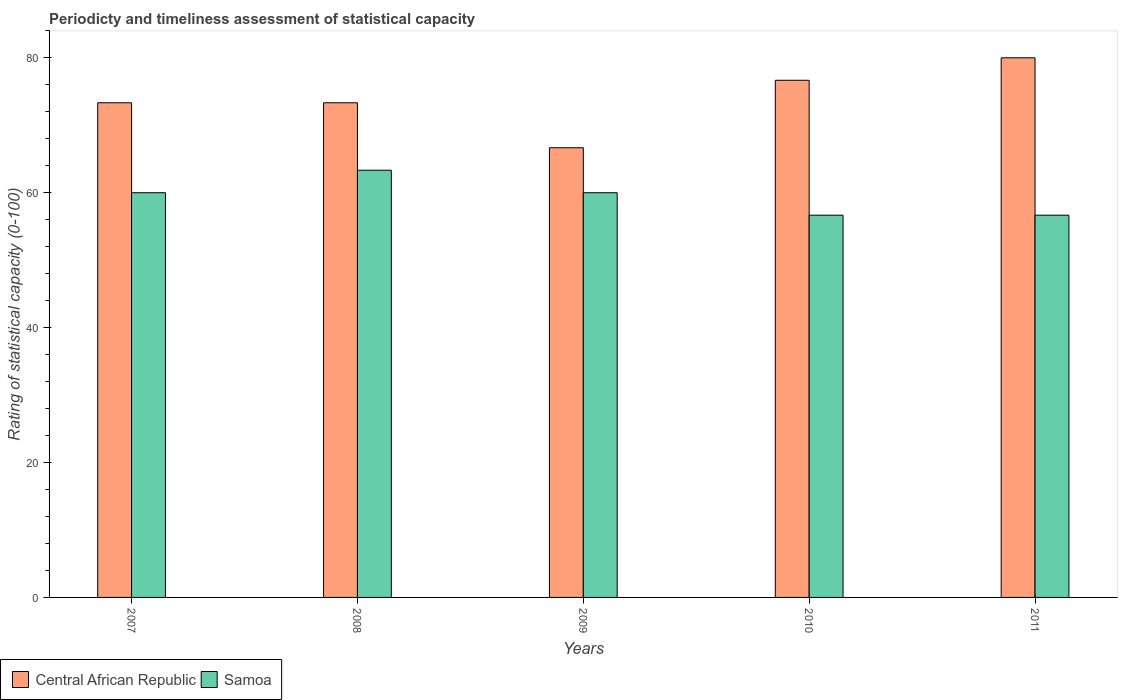How many bars are there on the 5th tick from the right?
Provide a succinct answer. 2. What is the rating of statistical capacity in Central African Republic in 2008?
Give a very brief answer. 73.33. Across all years, what is the maximum rating of statistical capacity in Samoa?
Keep it short and to the point. 63.33. Across all years, what is the minimum rating of statistical capacity in Samoa?
Ensure brevity in your answer.  56.67. What is the total rating of statistical capacity in Central African Republic in the graph?
Provide a short and direct response. 370. What is the difference between the rating of statistical capacity in Central African Republic in 2007 and that in 2010?
Your response must be concise. -3.33. What is the difference between the rating of statistical capacity in Samoa in 2010 and the rating of statistical capacity in Central African Republic in 2009?
Your answer should be very brief. -10. What is the average rating of statistical capacity in Samoa per year?
Your answer should be compact. 59.33. In the year 2009, what is the difference between the rating of statistical capacity in Central African Republic and rating of statistical capacity in Samoa?
Offer a very short reply. 6.67. In how many years, is the rating of statistical capacity in Central African Republic greater than 52?
Offer a very short reply. 5. What is the ratio of the rating of statistical capacity in Samoa in 2007 to that in 2011?
Offer a very short reply. 1.06. Is the rating of statistical capacity in Samoa in 2008 less than that in 2010?
Your response must be concise. No. Is the difference between the rating of statistical capacity in Central African Republic in 2009 and 2010 greater than the difference between the rating of statistical capacity in Samoa in 2009 and 2010?
Provide a succinct answer. No. What is the difference between the highest and the second highest rating of statistical capacity in Samoa?
Provide a succinct answer. 3.33. What is the difference between the highest and the lowest rating of statistical capacity in Samoa?
Give a very brief answer. 6.67. In how many years, is the rating of statistical capacity in Samoa greater than the average rating of statistical capacity in Samoa taken over all years?
Keep it short and to the point. 3. What does the 2nd bar from the left in 2010 represents?
Your answer should be very brief. Samoa. What does the 1st bar from the right in 2008 represents?
Make the answer very short. Samoa. Does the graph contain any zero values?
Offer a very short reply. No. Does the graph contain grids?
Offer a very short reply. No. Where does the legend appear in the graph?
Provide a short and direct response. Bottom left. How are the legend labels stacked?
Keep it short and to the point. Horizontal. What is the title of the graph?
Your answer should be very brief. Periodicty and timeliness assessment of statistical capacity. Does "Andorra" appear as one of the legend labels in the graph?
Your response must be concise. No. What is the label or title of the X-axis?
Keep it short and to the point. Years. What is the label or title of the Y-axis?
Offer a terse response. Rating of statistical capacity (0-100). What is the Rating of statistical capacity (0-100) in Central African Republic in 2007?
Ensure brevity in your answer.  73.33. What is the Rating of statistical capacity (0-100) of Central African Republic in 2008?
Keep it short and to the point. 73.33. What is the Rating of statistical capacity (0-100) of Samoa in 2008?
Your answer should be very brief. 63.33. What is the Rating of statistical capacity (0-100) in Central African Republic in 2009?
Your answer should be very brief. 66.67. What is the Rating of statistical capacity (0-100) in Central African Republic in 2010?
Keep it short and to the point. 76.67. What is the Rating of statistical capacity (0-100) of Samoa in 2010?
Offer a very short reply. 56.67. What is the Rating of statistical capacity (0-100) in Samoa in 2011?
Ensure brevity in your answer.  56.67. Across all years, what is the maximum Rating of statistical capacity (0-100) in Samoa?
Offer a very short reply. 63.33. Across all years, what is the minimum Rating of statistical capacity (0-100) in Central African Republic?
Offer a terse response. 66.67. Across all years, what is the minimum Rating of statistical capacity (0-100) in Samoa?
Ensure brevity in your answer.  56.67. What is the total Rating of statistical capacity (0-100) in Central African Republic in the graph?
Provide a succinct answer. 370. What is the total Rating of statistical capacity (0-100) in Samoa in the graph?
Provide a succinct answer. 296.67. What is the difference between the Rating of statistical capacity (0-100) of Central African Republic in 2007 and that in 2008?
Ensure brevity in your answer.  0. What is the difference between the Rating of statistical capacity (0-100) of Central African Republic in 2007 and that in 2009?
Offer a terse response. 6.67. What is the difference between the Rating of statistical capacity (0-100) of Samoa in 2007 and that in 2009?
Make the answer very short. 0. What is the difference between the Rating of statistical capacity (0-100) in Central African Republic in 2007 and that in 2011?
Ensure brevity in your answer.  -6.67. What is the difference between the Rating of statistical capacity (0-100) of Samoa in 2007 and that in 2011?
Offer a terse response. 3.33. What is the difference between the Rating of statistical capacity (0-100) of Central African Republic in 2008 and that in 2009?
Offer a very short reply. 6.67. What is the difference between the Rating of statistical capacity (0-100) in Central African Republic in 2008 and that in 2011?
Offer a terse response. -6.67. What is the difference between the Rating of statistical capacity (0-100) in Central African Republic in 2009 and that in 2010?
Offer a very short reply. -10. What is the difference between the Rating of statistical capacity (0-100) of Central African Republic in 2009 and that in 2011?
Make the answer very short. -13.33. What is the difference between the Rating of statistical capacity (0-100) of Samoa in 2009 and that in 2011?
Your response must be concise. 3.33. What is the difference between the Rating of statistical capacity (0-100) of Central African Republic in 2007 and the Rating of statistical capacity (0-100) of Samoa in 2009?
Offer a terse response. 13.33. What is the difference between the Rating of statistical capacity (0-100) of Central African Republic in 2007 and the Rating of statistical capacity (0-100) of Samoa in 2010?
Offer a terse response. 16.67. What is the difference between the Rating of statistical capacity (0-100) of Central African Republic in 2007 and the Rating of statistical capacity (0-100) of Samoa in 2011?
Your response must be concise. 16.67. What is the difference between the Rating of statistical capacity (0-100) of Central African Republic in 2008 and the Rating of statistical capacity (0-100) of Samoa in 2009?
Provide a short and direct response. 13.33. What is the difference between the Rating of statistical capacity (0-100) in Central African Republic in 2008 and the Rating of statistical capacity (0-100) in Samoa in 2010?
Your answer should be compact. 16.67. What is the difference between the Rating of statistical capacity (0-100) in Central African Republic in 2008 and the Rating of statistical capacity (0-100) in Samoa in 2011?
Make the answer very short. 16.67. What is the average Rating of statistical capacity (0-100) of Central African Republic per year?
Your response must be concise. 74. What is the average Rating of statistical capacity (0-100) in Samoa per year?
Your response must be concise. 59.33. In the year 2007, what is the difference between the Rating of statistical capacity (0-100) in Central African Republic and Rating of statistical capacity (0-100) in Samoa?
Offer a terse response. 13.33. In the year 2009, what is the difference between the Rating of statistical capacity (0-100) in Central African Republic and Rating of statistical capacity (0-100) in Samoa?
Make the answer very short. 6.67. In the year 2010, what is the difference between the Rating of statistical capacity (0-100) of Central African Republic and Rating of statistical capacity (0-100) of Samoa?
Your response must be concise. 20. In the year 2011, what is the difference between the Rating of statistical capacity (0-100) of Central African Republic and Rating of statistical capacity (0-100) of Samoa?
Your answer should be compact. 23.33. What is the ratio of the Rating of statistical capacity (0-100) in Central African Republic in 2007 to that in 2009?
Keep it short and to the point. 1.1. What is the ratio of the Rating of statistical capacity (0-100) of Samoa in 2007 to that in 2009?
Your answer should be very brief. 1. What is the ratio of the Rating of statistical capacity (0-100) in Central African Republic in 2007 to that in 2010?
Offer a very short reply. 0.96. What is the ratio of the Rating of statistical capacity (0-100) in Samoa in 2007 to that in 2010?
Ensure brevity in your answer.  1.06. What is the ratio of the Rating of statistical capacity (0-100) of Central African Republic in 2007 to that in 2011?
Ensure brevity in your answer.  0.92. What is the ratio of the Rating of statistical capacity (0-100) in Samoa in 2007 to that in 2011?
Your response must be concise. 1.06. What is the ratio of the Rating of statistical capacity (0-100) in Samoa in 2008 to that in 2009?
Provide a short and direct response. 1.06. What is the ratio of the Rating of statistical capacity (0-100) of Central African Republic in 2008 to that in 2010?
Offer a terse response. 0.96. What is the ratio of the Rating of statistical capacity (0-100) of Samoa in 2008 to that in 2010?
Provide a short and direct response. 1.12. What is the ratio of the Rating of statistical capacity (0-100) of Samoa in 2008 to that in 2011?
Keep it short and to the point. 1.12. What is the ratio of the Rating of statistical capacity (0-100) in Central African Republic in 2009 to that in 2010?
Make the answer very short. 0.87. What is the ratio of the Rating of statistical capacity (0-100) in Samoa in 2009 to that in 2010?
Provide a succinct answer. 1.06. What is the ratio of the Rating of statistical capacity (0-100) in Samoa in 2009 to that in 2011?
Ensure brevity in your answer.  1.06. What is the ratio of the Rating of statistical capacity (0-100) of Central African Republic in 2010 to that in 2011?
Your answer should be very brief. 0.96. What is the ratio of the Rating of statistical capacity (0-100) in Samoa in 2010 to that in 2011?
Your answer should be compact. 1. What is the difference between the highest and the second highest Rating of statistical capacity (0-100) of Samoa?
Offer a terse response. 3.33. What is the difference between the highest and the lowest Rating of statistical capacity (0-100) in Central African Republic?
Make the answer very short. 13.33. 